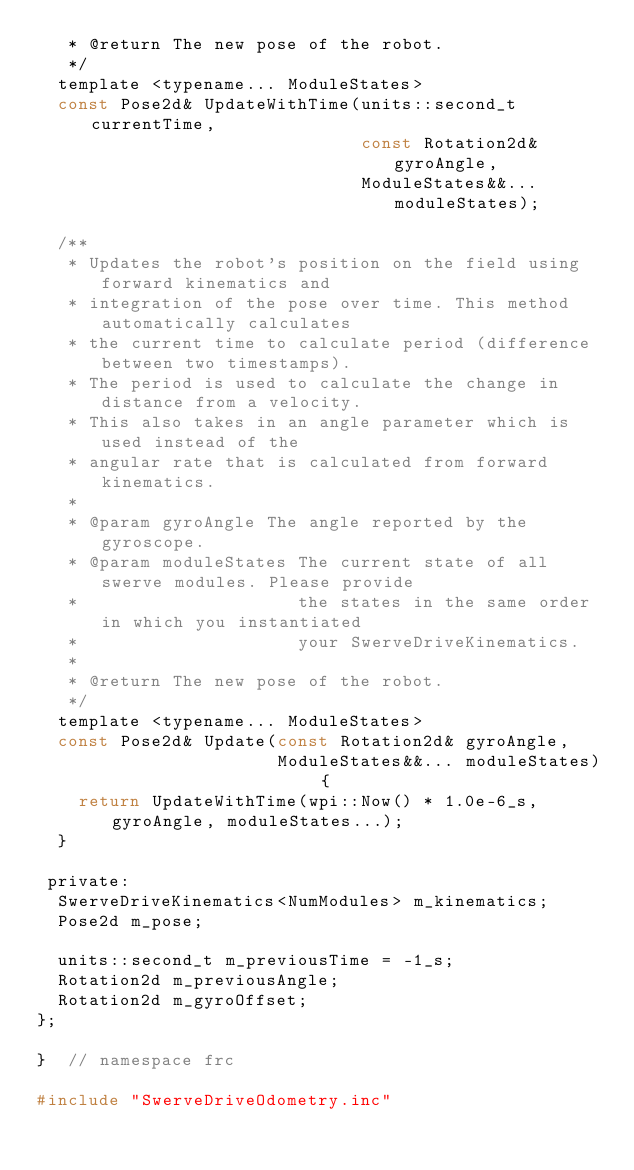<code> <loc_0><loc_0><loc_500><loc_500><_C_>   * @return The new pose of the robot.
   */
  template <typename... ModuleStates>
  const Pose2d& UpdateWithTime(units::second_t currentTime,
                               const Rotation2d& gyroAngle,
                               ModuleStates&&... moduleStates);

  /**
   * Updates the robot's position on the field using forward kinematics and
   * integration of the pose over time. This method automatically calculates
   * the current time to calculate period (difference between two timestamps).
   * The period is used to calculate the change in distance from a velocity.
   * This also takes in an angle parameter which is used instead of the
   * angular rate that is calculated from forward kinematics.
   *
   * @param gyroAngle The angle reported by the gyroscope.
   * @param moduleStates The current state of all swerve modules. Please provide
   *                     the states in the same order in which you instantiated
   *                     your SwerveDriveKinematics.
   *
   * @return The new pose of the robot.
   */
  template <typename... ModuleStates>
  const Pose2d& Update(const Rotation2d& gyroAngle,
                       ModuleStates&&... moduleStates) {
    return UpdateWithTime(wpi::Now() * 1.0e-6_s, gyroAngle, moduleStates...);
  }

 private:
  SwerveDriveKinematics<NumModules> m_kinematics;
  Pose2d m_pose;

  units::second_t m_previousTime = -1_s;
  Rotation2d m_previousAngle;
  Rotation2d m_gyroOffset;
};

}  // namespace frc

#include "SwerveDriveOdometry.inc"
</code> 